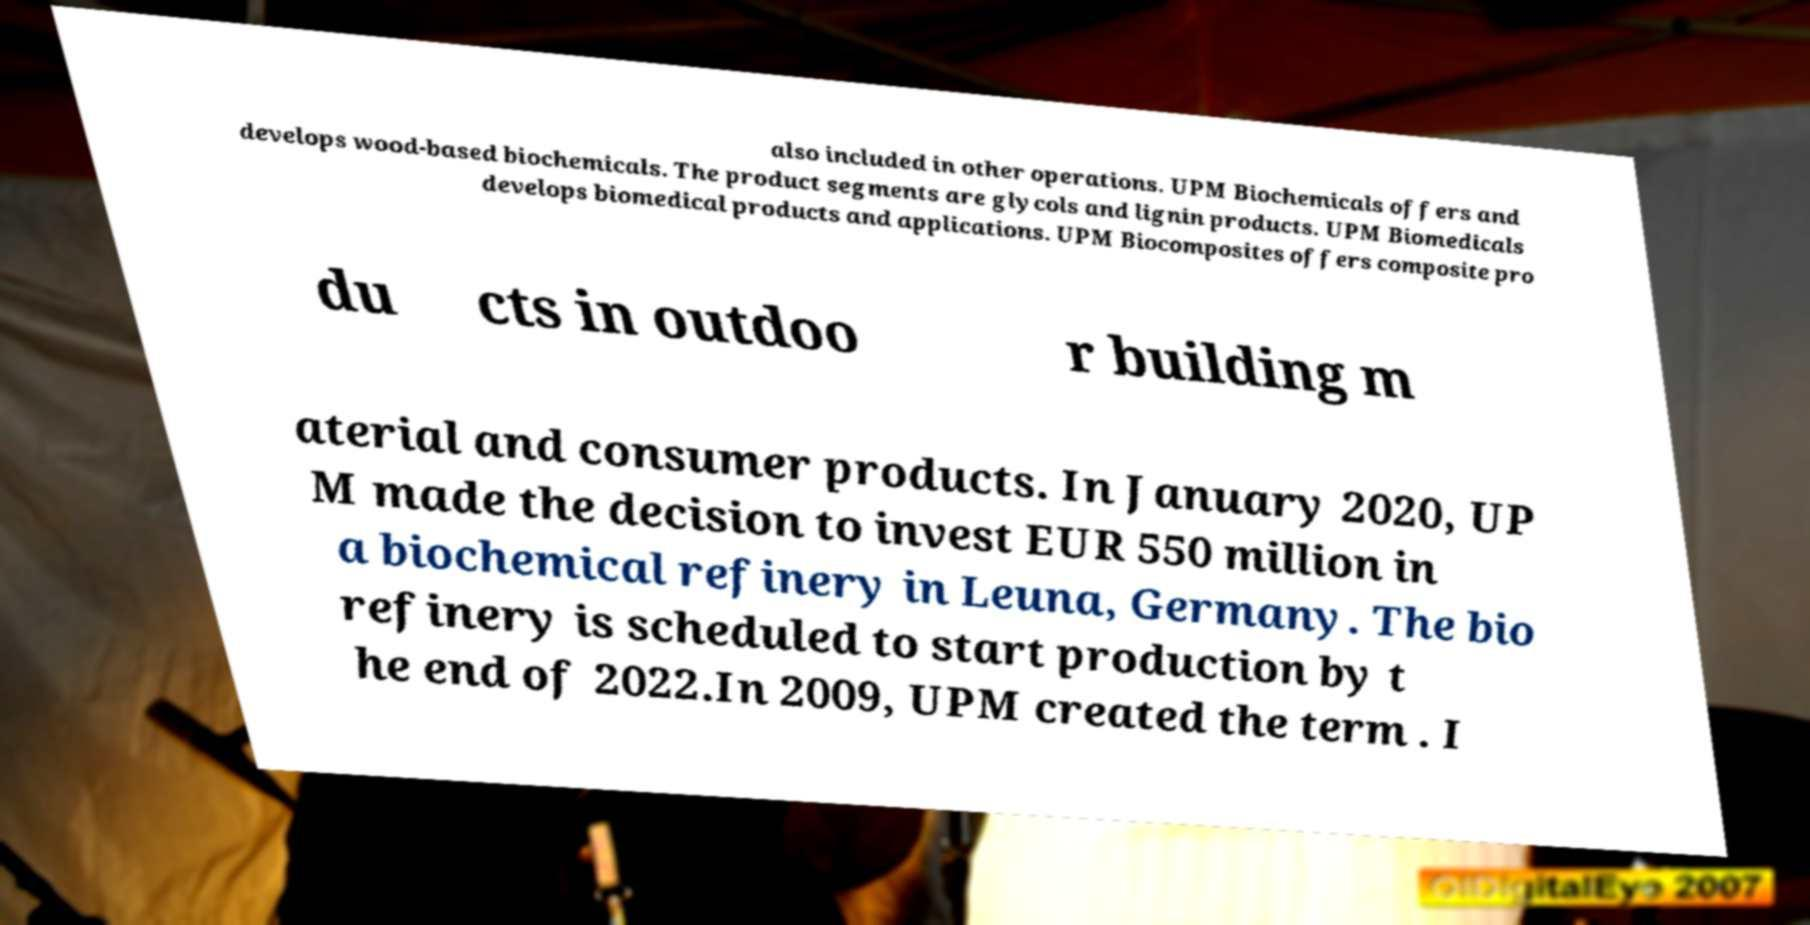I need the written content from this picture converted into text. Can you do that? also included in other operations. UPM Biochemicals offers and develops wood-based biochemicals. The product segments are glycols and lignin products. UPM Biomedicals develops biomedical products and applications. UPM Biocomposites offers composite pro du cts in outdoo r building m aterial and consumer products. In January 2020, UP M made the decision to invest EUR 550 million in a biochemical refinery in Leuna, Germany. The bio refinery is scheduled to start production by t he end of 2022.In 2009, UPM created the term . I 